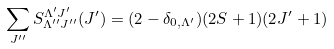<formula> <loc_0><loc_0><loc_500><loc_500>\sum _ { J ^ { \prime \prime } } S ^ { \Lambda ^ { \prime } J ^ { \prime } } _ { \Lambda ^ { \prime \prime } J ^ { \prime \prime } } ( J ^ { \prime } ) = ( 2 - \delta _ { 0 , \Lambda ^ { \prime } } ) ( 2 S + 1 ) ( 2 J ^ { \prime } + 1 )</formula> 